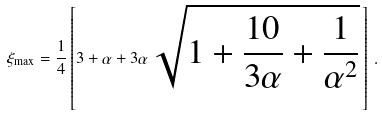<formula> <loc_0><loc_0><loc_500><loc_500>\xi _ { \max } = \frac { 1 } { 4 } \left [ 3 + \alpha + 3 \alpha \, \sqrt { 1 + \frac { 1 0 } { 3 \alpha } + \frac { 1 } { \alpha ^ { 2 } } } \, \right ] \, .</formula> 